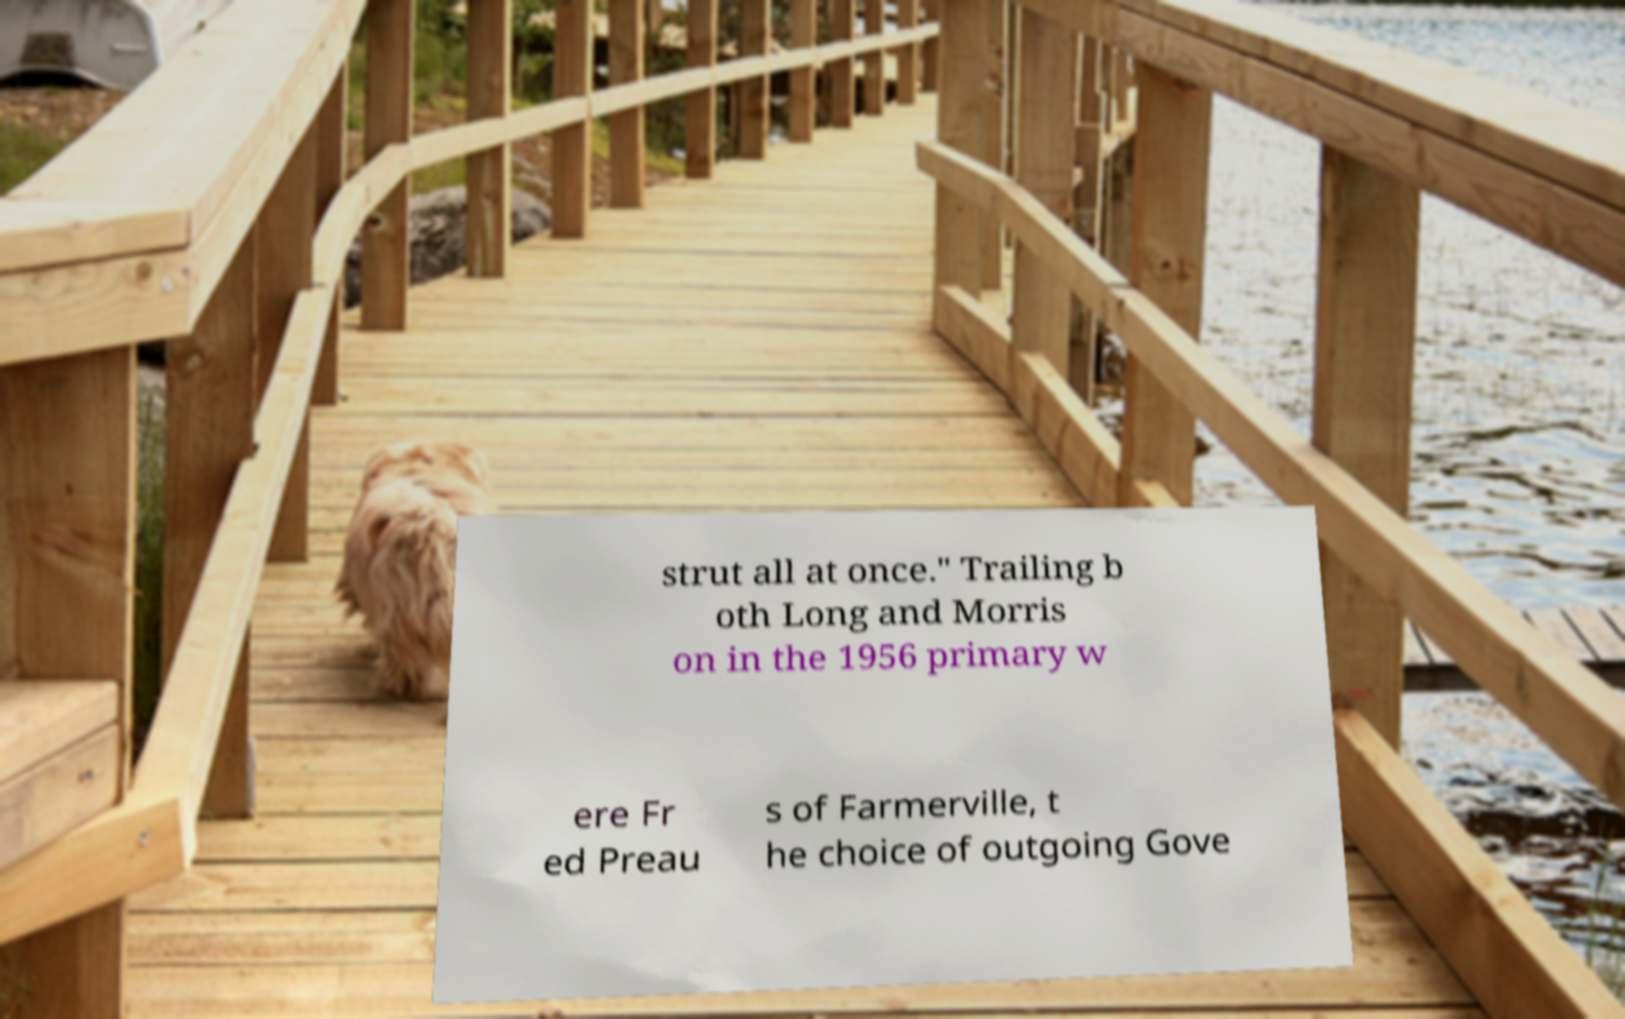Please read and relay the text visible in this image. What does it say? strut all at once." Trailing b oth Long and Morris on in the 1956 primary w ere Fr ed Preau s of Farmerville, t he choice of outgoing Gove 